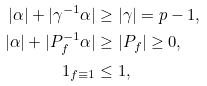Convert formula to latex. <formula><loc_0><loc_0><loc_500><loc_500>| \alpha | + | \gamma ^ { - 1 } \alpha | & \geq | \gamma | = p - 1 , \\ | \alpha | + | P _ { f } ^ { - 1 } \alpha | & \geq | P _ { f } | \geq 0 , \\ { 1 } _ { f \equiv 1 } & \leq 1 ,</formula> 